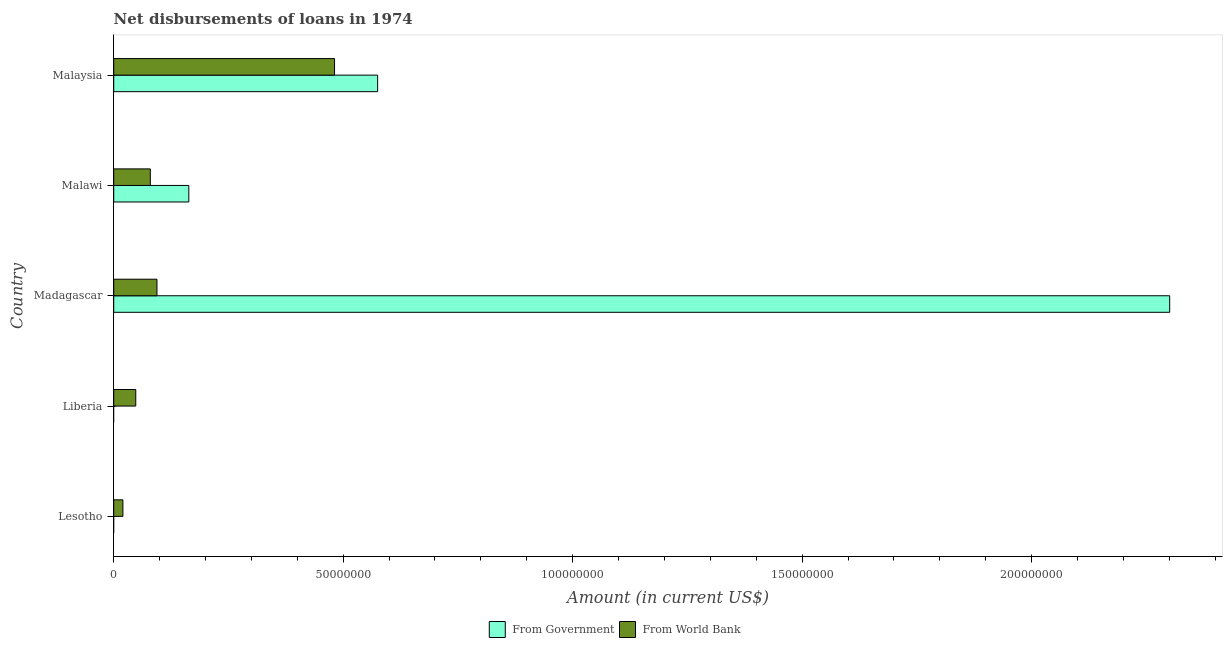How many different coloured bars are there?
Provide a succinct answer. 2. Are the number of bars per tick equal to the number of legend labels?
Offer a very short reply. No. Are the number of bars on each tick of the Y-axis equal?
Provide a short and direct response. No. How many bars are there on the 1st tick from the bottom?
Offer a very short reply. 1. What is the label of the 4th group of bars from the top?
Offer a very short reply. Liberia. What is the net disbursements of loan from government in Malawi?
Make the answer very short. 1.64e+07. Across all countries, what is the maximum net disbursements of loan from government?
Ensure brevity in your answer.  2.30e+08. Across all countries, what is the minimum net disbursements of loan from world bank?
Offer a terse response. 2.00e+06. In which country was the net disbursements of loan from government maximum?
Make the answer very short. Madagascar. What is the total net disbursements of loan from world bank in the graph?
Offer a terse response. 7.23e+07. What is the difference between the net disbursements of loan from world bank in Liberia and that in Madagascar?
Keep it short and to the point. -4.62e+06. What is the difference between the net disbursements of loan from world bank in Malaysia and the net disbursements of loan from government in Liberia?
Offer a terse response. 4.81e+07. What is the average net disbursements of loan from world bank per country?
Give a very brief answer. 1.45e+07. What is the difference between the net disbursements of loan from world bank and net disbursements of loan from government in Malawi?
Provide a succinct answer. -8.39e+06. In how many countries, is the net disbursements of loan from world bank greater than 220000000 US$?
Provide a succinct answer. 0. What is the ratio of the net disbursements of loan from government in Malawi to that in Malaysia?
Provide a short and direct response. 0.28. Is the net disbursements of loan from world bank in Lesotho less than that in Liberia?
Ensure brevity in your answer.  Yes. Is the difference between the net disbursements of loan from government in Madagascar and Malawi greater than the difference between the net disbursements of loan from world bank in Madagascar and Malawi?
Give a very brief answer. Yes. What is the difference between the highest and the second highest net disbursements of loan from government?
Provide a short and direct response. 1.73e+08. What is the difference between the highest and the lowest net disbursements of loan from government?
Provide a short and direct response. 2.30e+08. In how many countries, is the net disbursements of loan from world bank greater than the average net disbursements of loan from world bank taken over all countries?
Your answer should be compact. 1. Is the sum of the net disbursements of loan from world bank in Liberia and Madagascar greater than the maximum net disbursements of loan from government across all countries?
Provide a succinct answer. No. Are all the bars in the graph horizontal?
Offer a terse response. Yes. What is the difference between two consecutive major ticks on the X-axis?
Provide a succinct answer. 5.00e+07. Are the values on the major ticks of X-axis written in scientific E-notation?
Ensure brevity in your answer.  No. How many legend labels are there?
Your answer should be compact. 2. What is the title of the graph?
Provide a succinct answer. Net disbursements of loans in 1974. What is the label or title of the X-axis?
Keep it short and to the point. Amount (in current US$). What is the Amount (in current US$) of From World Bank in Lesotho?
Provide a succinct answer. 2.00e+06. What is the Amount (in current US$) in From World Bank in Liberia?
Give a very brief answer. 4.80e+06. What is the Amount (in current US$) in From Government in Madagascar?
Offer a terse response. 2.30e+08. What is the Amount (in current US$) in From World Bank in Madagascar?
Your response must be concise. 9.42e+06. What is the Amount (in current US$) of From Government in Malawi?
Ensure brevity in your answer.  1.64e+07. What is the Amount (in current US$) in From World Bank in Malawi?
Offer a terse response. 7.97e+06. What is the Amount (in current US$) in From Government in Malaysia?
Offer a terse response. 5.75e+07. What is the Amount (in current US$) in From World Bank in Malaysia?
Your answer should be very brief. 4.81e+07. Across all countries, what is the maximum Amount (in current US$) of From Government?
Your answer should be very brief. 2.30e+08. Across all countries, what is the maximum Amount (in current US$) in From World Bank?
Your answer should be compact. 4.81e+07. Across all countries, what is the minimum Amount (in current US$) of From Government?
Offer a very short reply. 0. Across all countries, what is the minimum Amount (in current US$) of From World Bank?
Make the answer very short. 2.00e+06. What is the total Amount (in current US$) of From Government in the graph?
Give a very brief answer. 3.04e+08. What is the total Amount (in current US$) in From World Bank in the graph?
Ensure brevity in your answer.  7.23e+07. What is the difference between the Amount (in current US$) of From World Bank in Lesotho and that in Liberia?
Your answer should be very brief. -2.80e+06. What is the difference between the Amount (in current US$) of From World Bank in Lesotho and that in Madagascar?
Keep it short and to the point. -7.42e+06. What is the difference between the Amount (in current US$) of From World Bank in Lesotho and that in Malawi?
Provide a succinct answer. -5.97e+06. What is the difference between the Amount (in current US$) in From World Bank in Lesotho and that in Malaysia?
Ensure brevity in your answer.  -4.61e+07. What is the difference between the Amount (in current US$) of From World Bank in Liberia and that in Madagascar?
Make the answer very short. -4.62e+06. What is the difference between the Amount (in current US$) in From World Bank in Liberia and that in Malawi?
Your answer should be very brief. -3.17e+06. What is the difference between the Amount (in current US$) in From World Bank in Liberia and that in Malaysia?
Offer a terse response. -4.33e+07. What is the difference between the Amount (in current US$) in From Government in Madagascar and that in Malawi?
Ensure brevity in your answer.  2.14e+08. What is the difference between the Amount (in current US$) in From World Bank in Madagascar and that in Malawi?
Make the answer very short. 1.45e+06. What is the difference between the Amount (in current US$) in From Government in Madagascar and that in Malaysia?
Your answer should be very brief. 1.73e+08. What is the difference between the Amount (in current US$) of From World Bank in Madagascar and that in Malaysia?
Your answer should be compact. -3.87e+07. What is the difference between the Amount (in current US$) in From Government in Malawi and that in Malaysia?
Give a very brief answer. -4.11e+07. What is the difference between the Amount (in current US$) in From World Bank in Malawi and that in Malaysia?
Your response must be concise. -4.01e+07. What is the difference between the Amount (in current US$) in From Government in Madagascar and the Amount (in current US$) in From World Bank in Malawi?
Ensure brevity in your answer.  2.22e+08. What is the difference between the Amount (in current US$) in From Government in Madagascar and the Amount (in current US$) in From World Bank in Malaysia?
Provide a short and direct response. 1.82e+08. What is the difference between the Amount (in current US$) of From Government in Malawi and the Amount (in current US$) of From World Bank in Malaysia?
Ensure brevity in your answer.  -3.18e+07. What is the average Amount (in current US$) of From Government per country?
Provide a short and direct response. 6.08e+07. What is the average Amount (in current US$) in From World Bank per country?
Give a very brief answer. 1.45e+07. What is the difference between the Amount (in current US$) of From Government and Amount (in current US$) of From World Bank in Madagascar?
Your answer should be compact. 2.21e+08. What is the difference between the Amount (in current US$) in From Government and Amount (in current US$) in From World Bank in Malawi?
Provide a short and direct response. 8.39e+06. What is the difference between the Amount (in current US$) of From Government and Amount (in current US$) of From World Bank in Malaysia?
Offer a very short reply. 9.39e+06. What is the ratio of the Amount (in current US$) in From World Bank in Lesotho to that in Liberia?
Give a very brief answer. 0.42. What is the ratio of the Amount (in current US$) of From World Bank in Lesotho to that in Madagascar?
Offer a terse response. 0.21. What is the ratio of the Amount (in current US$) in From World Bank in Lesotho to that in Malawi?
Make the answer very short. 0.25. What is the ratio of the Amount (in current US$) of From World Bank in Lesotho to that in Malaysia?
Provide a succinct answer. 0.04. What is the ratio of the Amount (in current US$) in From World Bank in Liberia to that in Madagascar?
Make the answer very short. 0.51. What is the ratio of the Amount (in current US$) in From World Bank in Liberia to that in Malawi?
Your answer should be very brief. 0.6. What is the ratio of the Amount (in current US$) of From World Bank in Liberia to that in Malaysia?
Your answer should be very brief. 0.1. What is the ratio of the Amount (in current US$) of From Government in Madagascar to that in Malawi?
Your answer should be very brief. 14.06. What is the ratio of the Amount (in current US$) in From World Bank in Madagascar to that in Malawi?
Offer a very short reply. 1.18. What is the ratio of the Amount (in current US$) in From Government in Madagascar to that in Malaysia?
Provide a short and direct response. 4. What is the ratio of the Amount (in current US$) of From World Bank in Madagascar to that in Malaysia?
Your answer should be very brief. 0.2. What is the ratio of the Amount (in current US$) in From Government in Malawi to that in Malaysia?
Offer a terse response. 0.28. What is the ratio of the Amount (in current US$) in From World Bank in Malawi to that in Malaysia?
Provide a succinct answer. 0.17. What is the difference between the highest and the second highest Amount (in current US$) of From Government?
Your response must be concise. 1.73e+08. What is the difference between the highest and the second highest Amount (in current US$) of From World Bank?
Keep it short and to the point. 3.87e+07. What is the difference between the highest and the lowest Amount (in current US$) of From Government?
Offer a very short reply. 2.30e+08. What is the difference between the highest and the lowest Amount (in current US$) of From World Bank?
Offer a very short reply. 4.61e+07. 